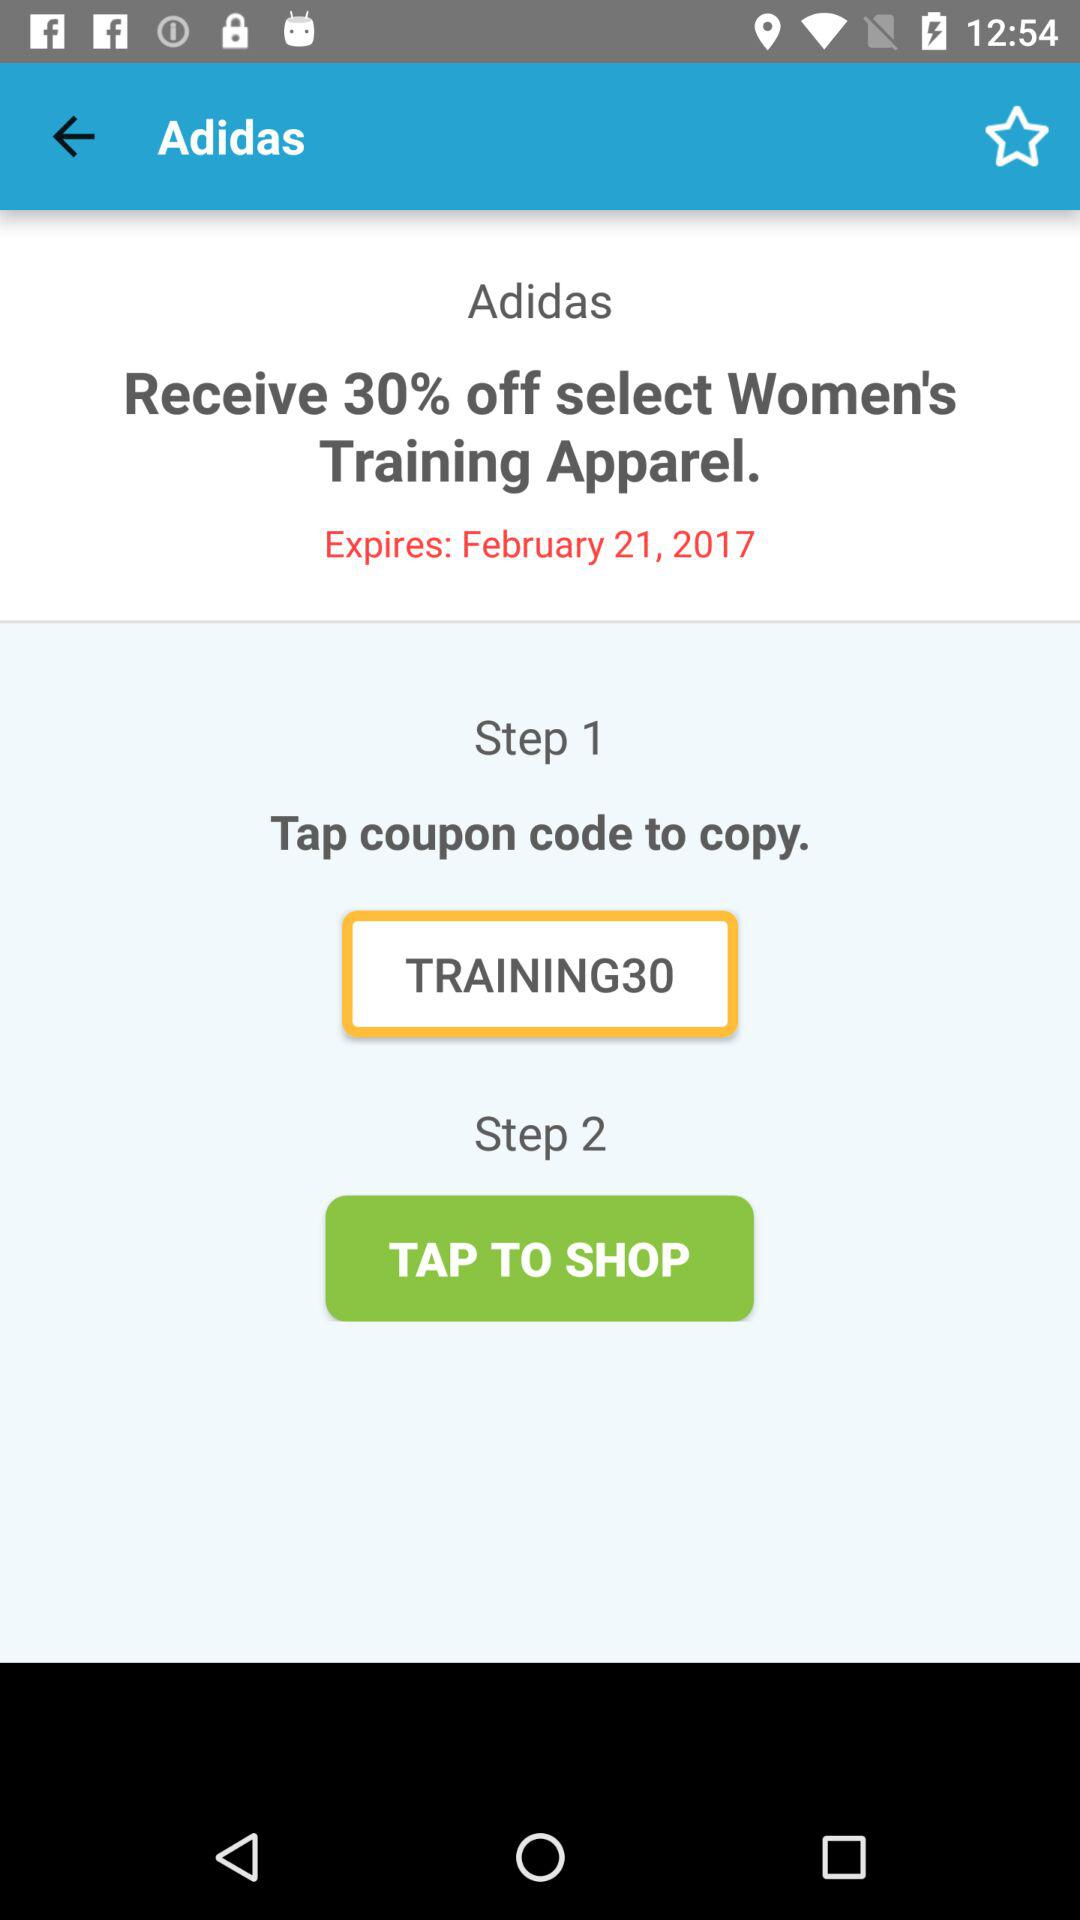How many steps are there in this coupon?
Answer the question using a single word or phrase. 2 